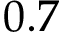Convert formula to latex. <formula><loc_0><loc_0><loc_500><loc_500>0 . 7</formula> 